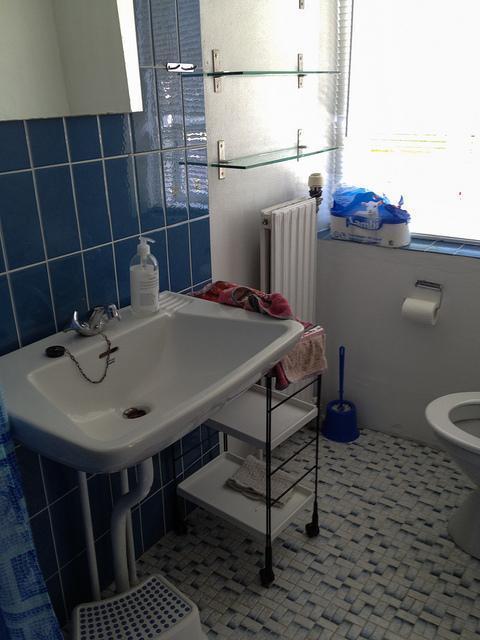What is usually done here?
Indicate the correct choice and explain in the format: 'Answer: answer
Rationale: rationale.'
Options: Sleeping, teeth brushing, watching tv, cooking eggs. Answer: teeth brushing.
Rationale: Here we see a bathroom sink. although no toothbrushes are visible brushing teeth is something that would normally take place here. 